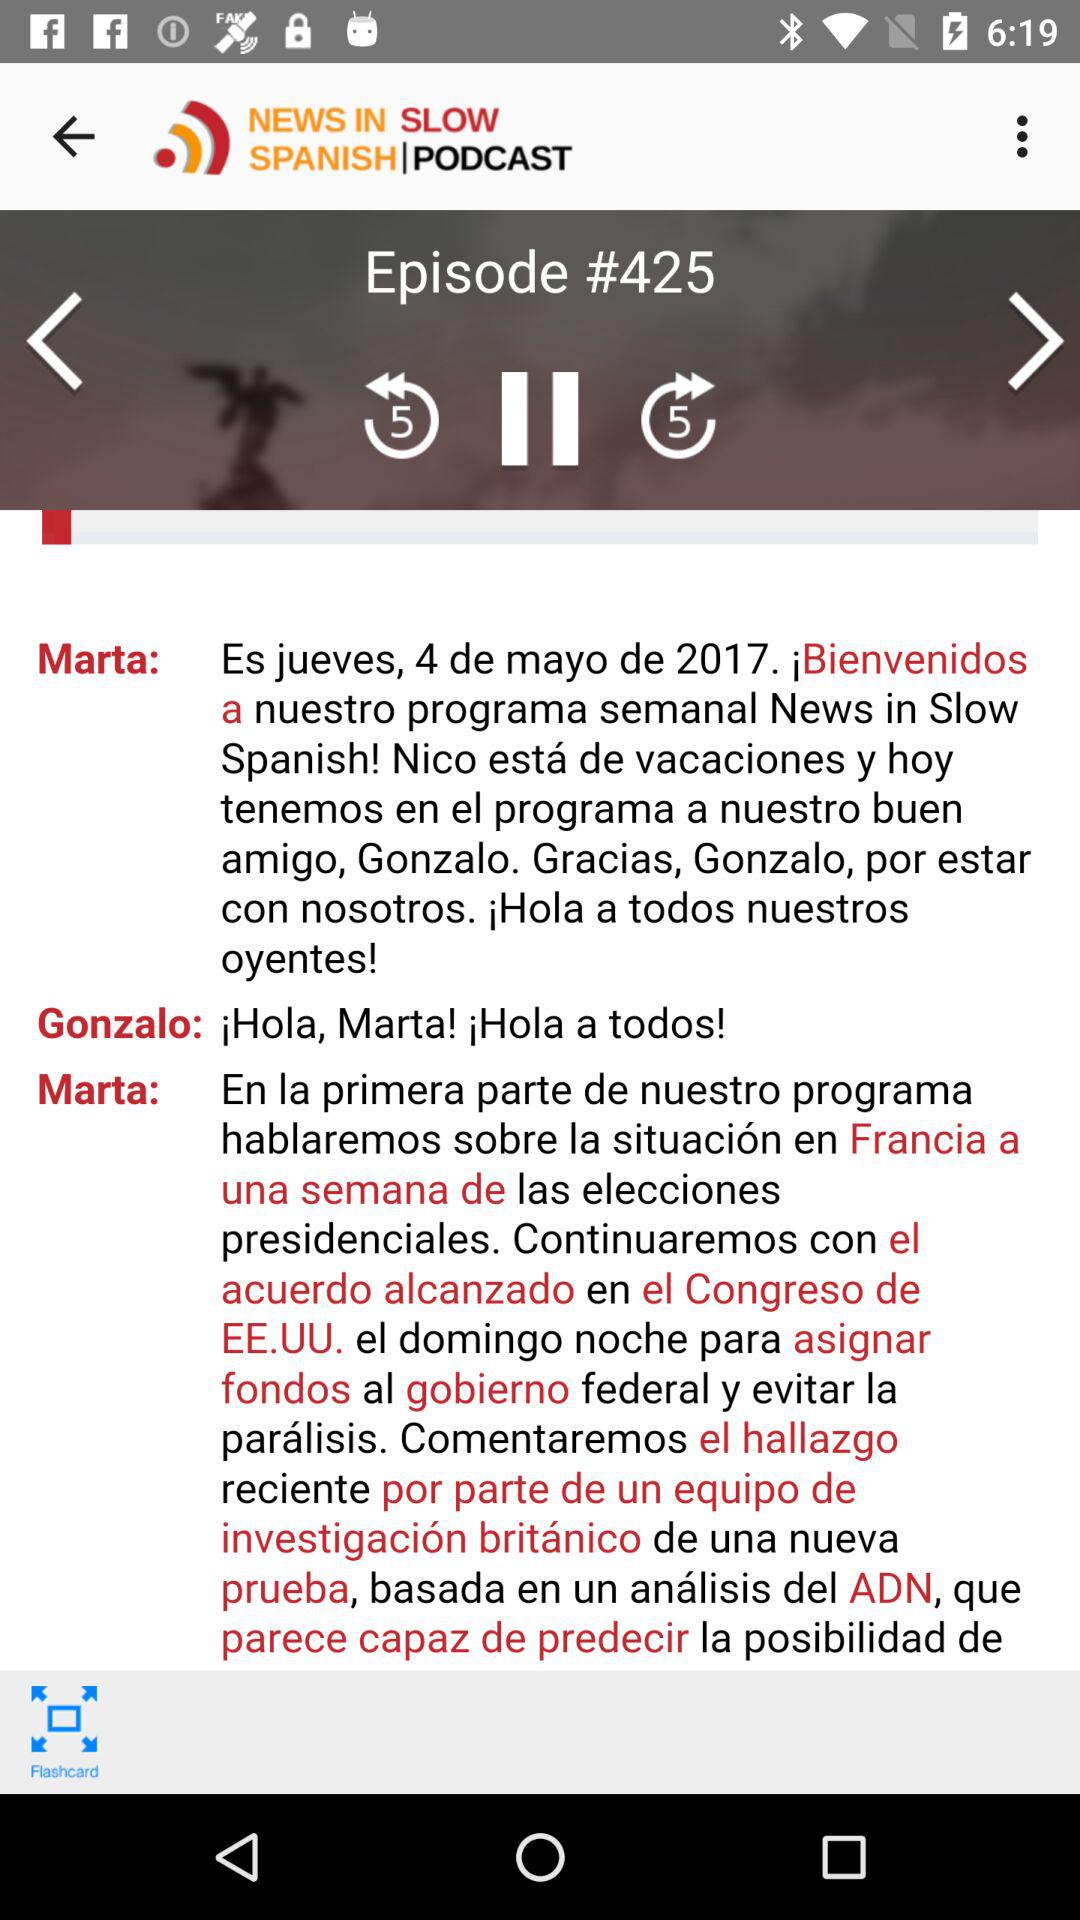What is the episode number of the podcast? The episode number is #425. 